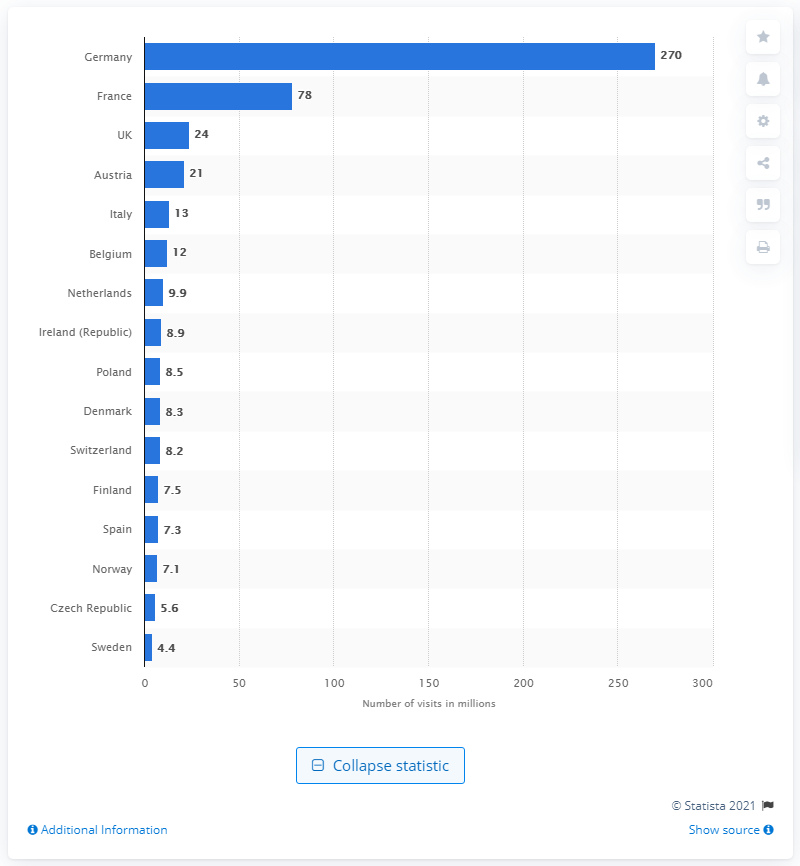Mention a couple of crucial points in this snapshot. According to data from 2013, approximately 24 people visited Christmas markets in the UK. 